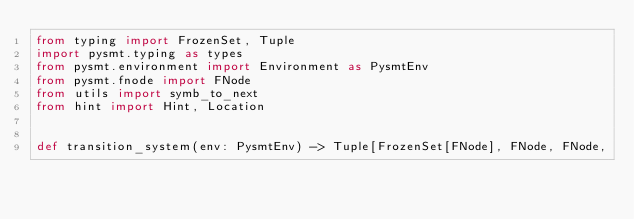<code> <loc_0><loc_0><loc_500><loc_500><_Python_>from typing import FrozenSet, Tuple
import pysmt.typing as types
from pysmt.environment import Environment as PysmtEnv
from pysmt.fnode import FNode
from utils import symb_to_next
from hint import Hint, Location


def transition_system(env: PysmtEnv) -> Tuple[FrozenSet[FNode], FNode, FNode,</code> 